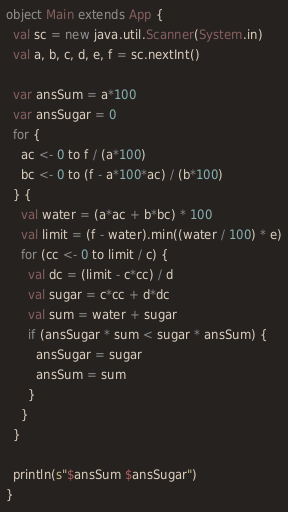<code> <loc_0><loc_0><loc_500><loc_500><_Scala_>object Main extends App {
  val sc = new java.util.Scanner(System.in)
  val a, b, c, d, e, f = sc.nextInt()

  var ansSum = a*100
  var ansSugar = 0
  for {
    ac <- 0 to f / (a*100)
    bc <- 0 to (f - a*100*ac) / (b*100)
  } {
    val water = (a*ac + b*bc) * 100
    val limit = (f - water).min((water / 100) * e)
    for (cc <- 0 to limit / c) {
      val dc = (limit - c*cc) / d
      val sugar = c*cc + d*dc
      val sum = water + sugar
      if (ansSugar * sum < sugar * ansSum) {
        ansSugar = sugar
        ansSum = sum
      }
    }
  }

  println(s"$ansSum $ansSugar")
}
</code> 